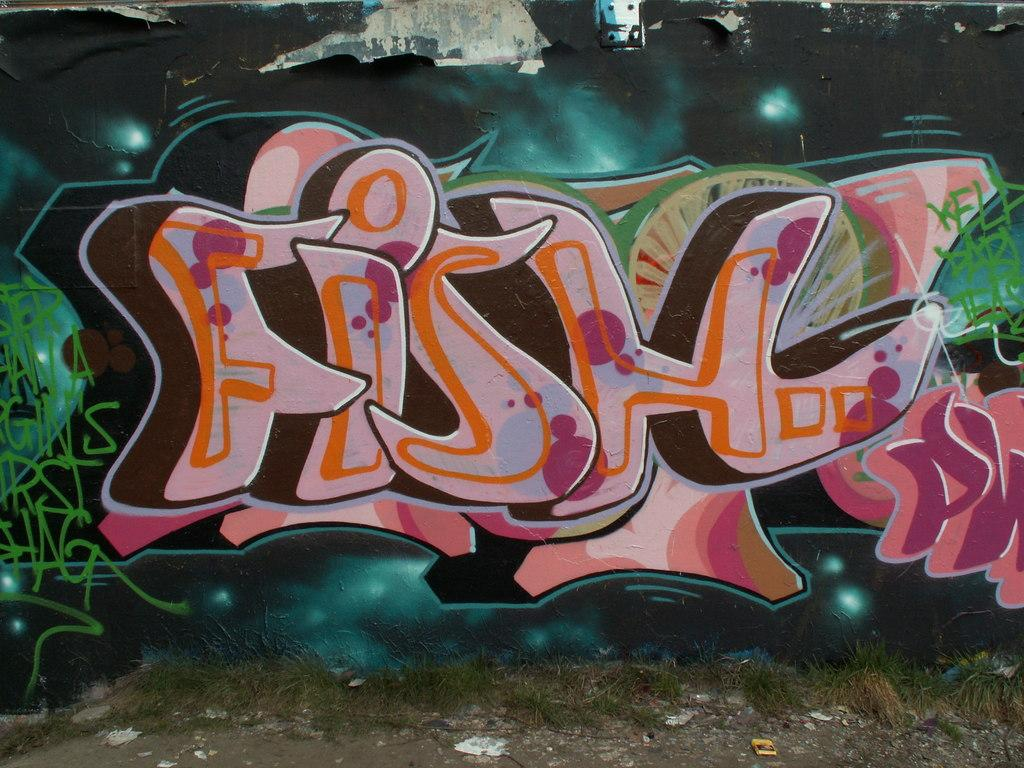What type of vegetation is present in the image? There is grass in the image. What can be seen on the path in the image? There are objects on a path in the image. What is written or displayed on a wall in the image? There is text visible on a wall in the image. What type of artwork is present on the wall in the image? There is a painting on the wall in the image. How many geese are flying over the grass in the image? There are no geese present in the image. What type of glue is used to attach the painting to the wall in the image? There is no information about glue or any adhesive used to attach the painting to the wall in the image. 